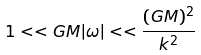<formula> <loc_0><loc_0><loc_500><loc_500>1 < < G M | \omega | < < { \frac { ( G M ) ^ { 2 } } { k ^ { 2 } } }</formula> 